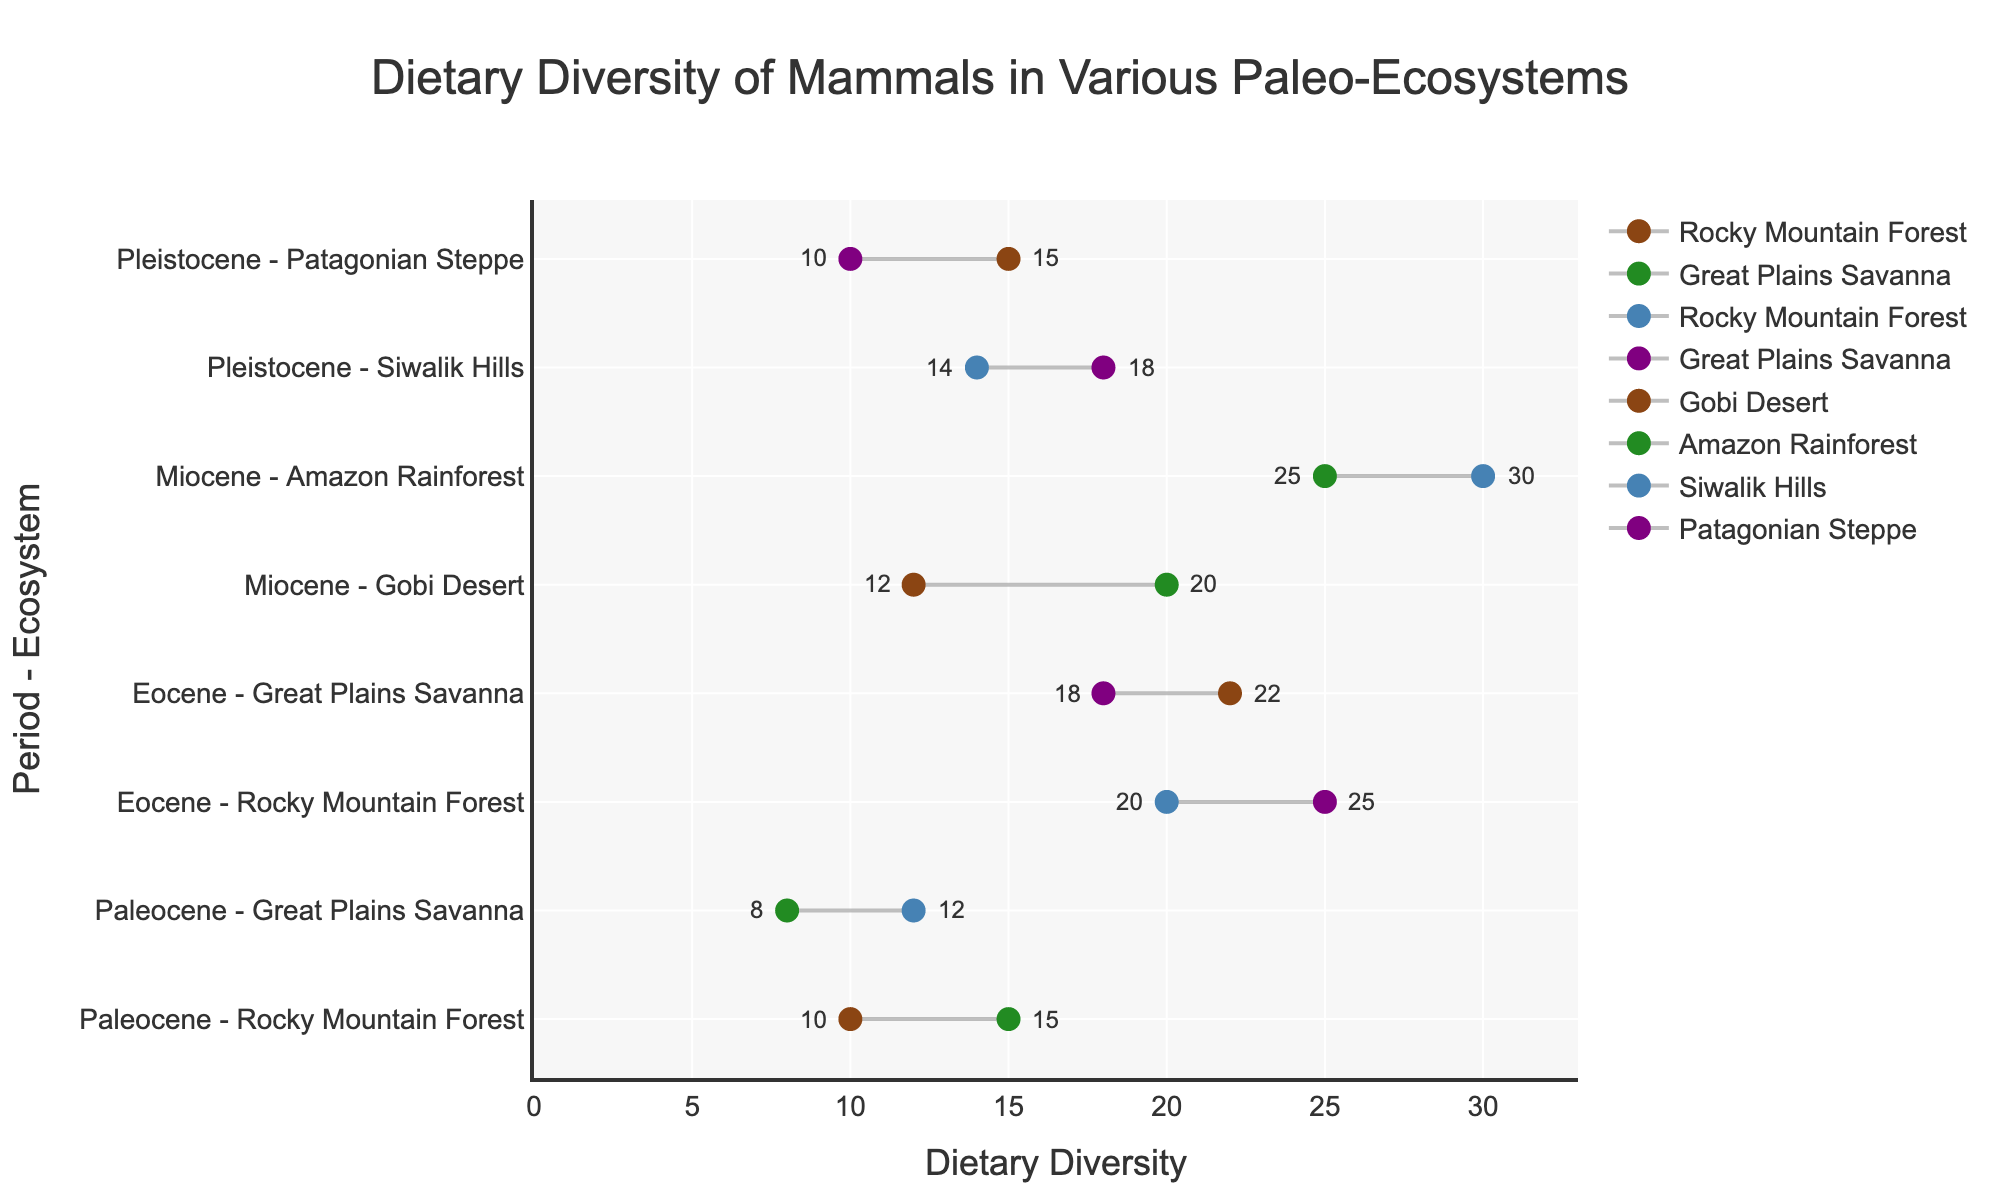What is the title of the plot? The title of the plot is prominently displayed at the top of the figure and reads "Dietary Diversity of Mammals in Various Paleo-Ecosystems."
Answer: Dietary Diversity of Mammals in Various Paleo-Ecosystems How many ecosystems are represented in the figure? Each period listed has different ecosystems associated with it. By counting them, we see there are 8 ecosystems total.
Answer: 8 Which ecosystem in the Eocene period had the highest final dietary diversity? In the Eocene period, we compare the final dietary diversity values of both ecosystems: Rocky Mountain Forest (25) and Great Plains Savanna (22). The highest value is 25.
Answer: Rocky Mountain Forest What is the range of dietary diversity for the Miocene Amazon Rainforest ecosystem? The initial dietary diversity is 25, and the final dietary diversity is 30. The range is calculated as the difference between these values: 30 - 25.
Answer: 5 Which period and ecosystem combination shows the smallest increase in dietary diversity? By comparing the differences between initial and final values for each combination: 
(1) Paleocene, Rocky Mountain Forest: 15 - 10 = 5 
(2) Paleocene, Great Plains Savanna: 12 - 8 = 4 
(3) Eocene, Rocky Mountain Forest: 25 - 20 = 5 
(4) Eocene, Great Plains Savanna: 22 - 18 = 4 
(5) Miocene, Gobi Desert: 20 - 12 = 8 
(6) Miocene, Amazon Rainforest: 30 - 25 = 5 
(7) Pleistocene, Siwalik Hills: 18 - 14 = 4 
(8) Pleistocene, Patagonian Steppe: 15 - 10 = 5 
The smallest increase (4) is seen in Paleocene Great Plains Savanna, Eocene Great Plains Savanna, and Pleistocene Siwalik Hills.
Answer: Paleocene Great Plains Savanna, Eocene Great Plains Savanna, Pleistocene Siwalik Hills What is the sum of initial dietary diversity values across all ecosystems? Summing the values: 10 (Paleocene Rocky Mountain Forest) + 8 (Paleocene Great Plains Savanna) + 20 (Eocene Rocky Mountain Forest) + 18 (Eocene Great Plains Savanna) + 12 (Miocene Gobi Desert) + 25 (Miocene Amazon Rainforest) + 14 (Pleistocene Siwalik Hills) + 10 (Pleistocene Patagonian Steppe) results in: 10 + 8 + 20 + 18 + 12 + 25 + 14 + 10 = 117.
Answer: 117 Which Paleo-Ecosystem experienced the largest increase in dietary diversity? To find the largest increase, we calculate the difference between initial and final diversity for each ecosystem:
(1) Paleocene Rocky Mountain Forest: 15 - 10 = 5
(2) Paleocene Great Plains Savanna: 12 - 8 = 4
(3) Eocene Rocky Mountain Forest: 25 - 20 = 5
(4) Eocene Great Plains Savanna: 22 - 18 = 4
(5) Miocene Gobi Desert: 20 - 12 = 8
(6) Miocene Amazon Rainforest: 30 - 25 = 5
(7) Pleistocene Siwalik Hills: 18 - 14 = 4
(8) Pleistocene Patagonian Steppe: 15 - 10 = 5
The largest increase is observed in the Miocene Gobi Desert with an increase of 8.
Answer: Miocene Gobi Desert Is there any ecosystem where the final dietary diversity is less than or equal to its initial dietary diversity? Checking each pair of values, all final values are greater than their respective initial values. Thus, no ecosystem fulfills this condition.
Answer: No What is the average final dietary diversity for ecosystems during the Pleistocene period? For the Pleistocene period, the final dietary diversity values are: Siwalik Hills (18) and Patagonian Steppe (15). The average is calculated as (18 + 15) / 2.
Answer: 16.5 